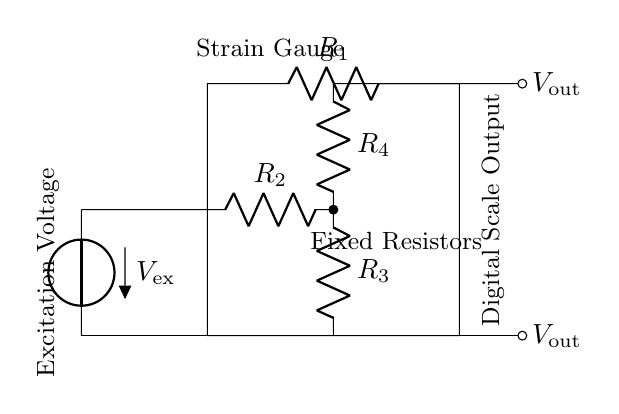What components are in this circuit? The circuit contains four resistors and one voltage source. This includes R1, R2, R3, and R4 as the resistors, and Vex as the excitation voltage source.
Answer: Four resistors and one voltage source What is the purpose of the resistors in this circuit? The resistors are used to create a Wheatstone bridge, which allows for accurate measurement of resistance changes, specifically from the strain gauges connected to the circuit.
Answer: To measure resistance changes What is the type of this circuit? This is a strain gauge bridge circuit, typically used for weighing and measuring deformation in materials. The configuration is essential for precise weight measurements.
Answer: Strain gauge bridge What is the output of this circuit? The output of the circuit is represented as Vout, which indicates the voltage change due to the strain experienced by the strain gauges, translated into weight measurements.
Answer: Vout What does the voltage source provide in this circuit? The voltage source supplies excitation voltage (Vex) necessary to power the strain gauges, allowing them to detect changes in resistive load when weight is applied.
Answer: Excitation voltage What effect does changing the resistance of one strain gauge have on the output voltage? Changing the resistance of one strain gauge alters the balance of the Wheatstone bridge, creating a differential output voltage that reflects the applied weight.
Answer: Alters output voltage What does the digital scale output signify in this context? The digital scale output signifies the processed measurement corresponding to the weight applied, which is displayed based on the voltage readings and the calibration of the scale.
Answer: Weight measurement 